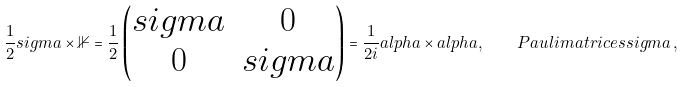<formula> <loc_0><loc_0><loc_500><loc_500>\frac { 1 } { 2 } s i g m a \times \mathbb { 1 } = \frac { 1 } { 2 } \begin{pmatrix} s i g m a & 0 \\ 0 & s i g m a \end{pmatrix} = \frac { 1 } { 2 i } a l p h a \times a l p h a , \quad P a u l i m a t r i c e s s i g m a \, ,</formula> 